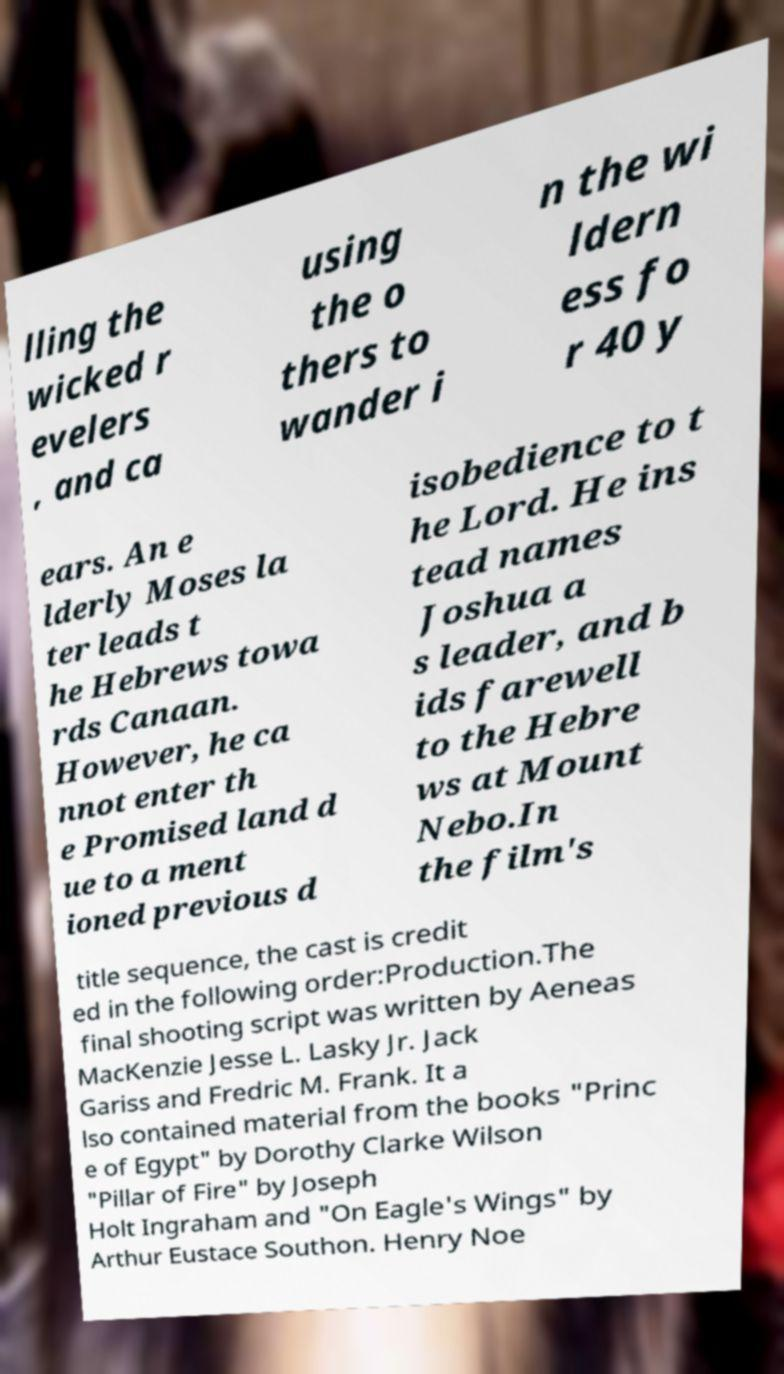Could you assist in decoding the text presented in this image and type it out clearly? lling the wicked r evelers , and ca using the o thers to wander i n the wi ldern ess fo r 40 y ears. An e lderly Moses la ter leads t he Hebrews towa rds Canaan. However, he ca nnot enter th e Promised land d ue to a ment ioned previous d isobedience to t he Lord. He ins tead names Joshua a s leader, and b ids farewell to the Hebre ws at Mount Nebo.In the film's title sequence, the cast is credit ed in the following order:Production.The final shooting script was written by Aeneas MacKenzie Jesse L. Lasky Jr. Jack Gariss and Fredric M. Frank. It a lso contained material from the books "Princ e of Egypt" by Dorothy Clarke Wilson "Pillar of Fire" by Joseph Holt Ingraham and "On Eagle's Wings" by Arthur Eustace Southon. Henry Noe 